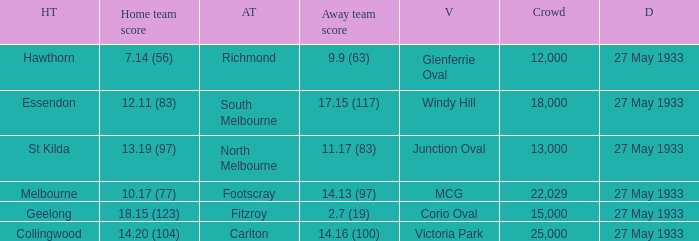In the match where the home team scored 14.20 (104), how many attendees were in the crowd? 25000.0. 